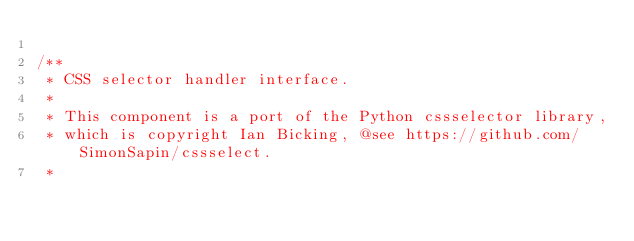Convert code to text. <code><loc_0><loc_0><loc_500><loc_500><_PHP_>
/**
 * CSS selector handler interface.
 *
 * This component is a port of the Python cssselector library,
 * which is copyright Ian Bicking, @see https://github.com/SimonSapin/cssselect.
 *</code> 